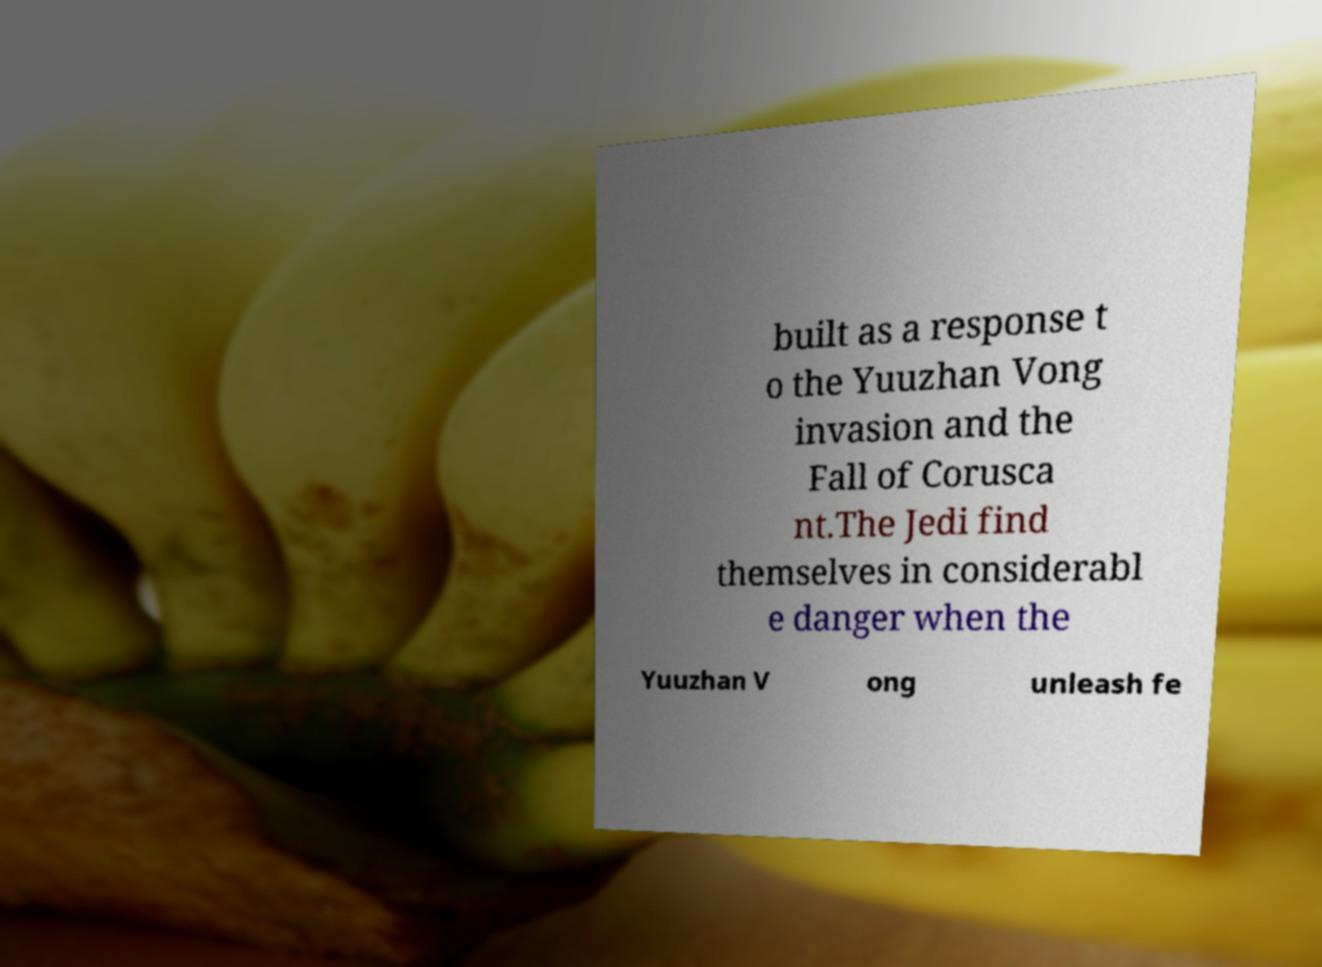Can you read and provide the text displayed in the image?This photo seems to have some interesting text. Can you extract and type it out for me? built as a response t o the Yuuzhan Vong invasion and the Fall of Corusca nt.The Jedi find themselves in considerabl e danger when the Yuuzhan V ong unleash fe 